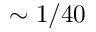Convert formula to latex. <formula><loc_0><loc_0><loc_500><loc_500>\sim 1 / 4 0</formula> 